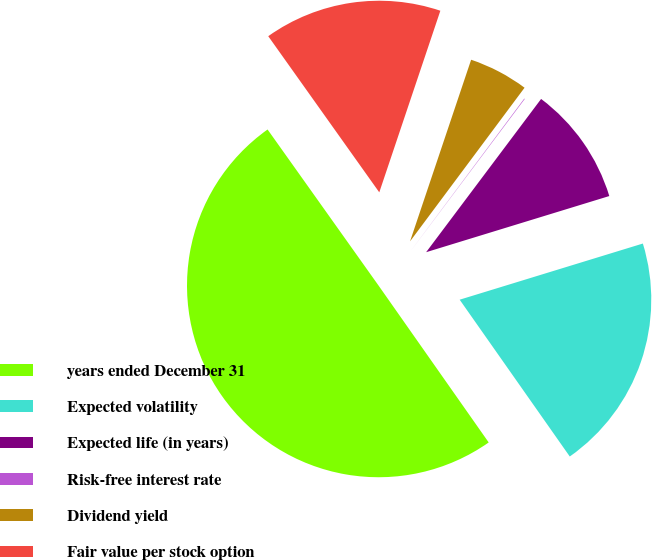Convert chart to OTSL. <chart><loc_0><loc_0><loc_500><loc_500><pie_chart><fcel>years ended December 31<fcel>Expected volatility<fcel>Expected life (in years)<fcel>Risk-free interest rate<fcel>Dividend yield<fcel>Fair value per stock option<nl><fcel>49.9%<fcel>19.99%<fcel>10.02%<fcel>0.05%<fcel>5.03%<fcel>15.0%<nl></chart> 